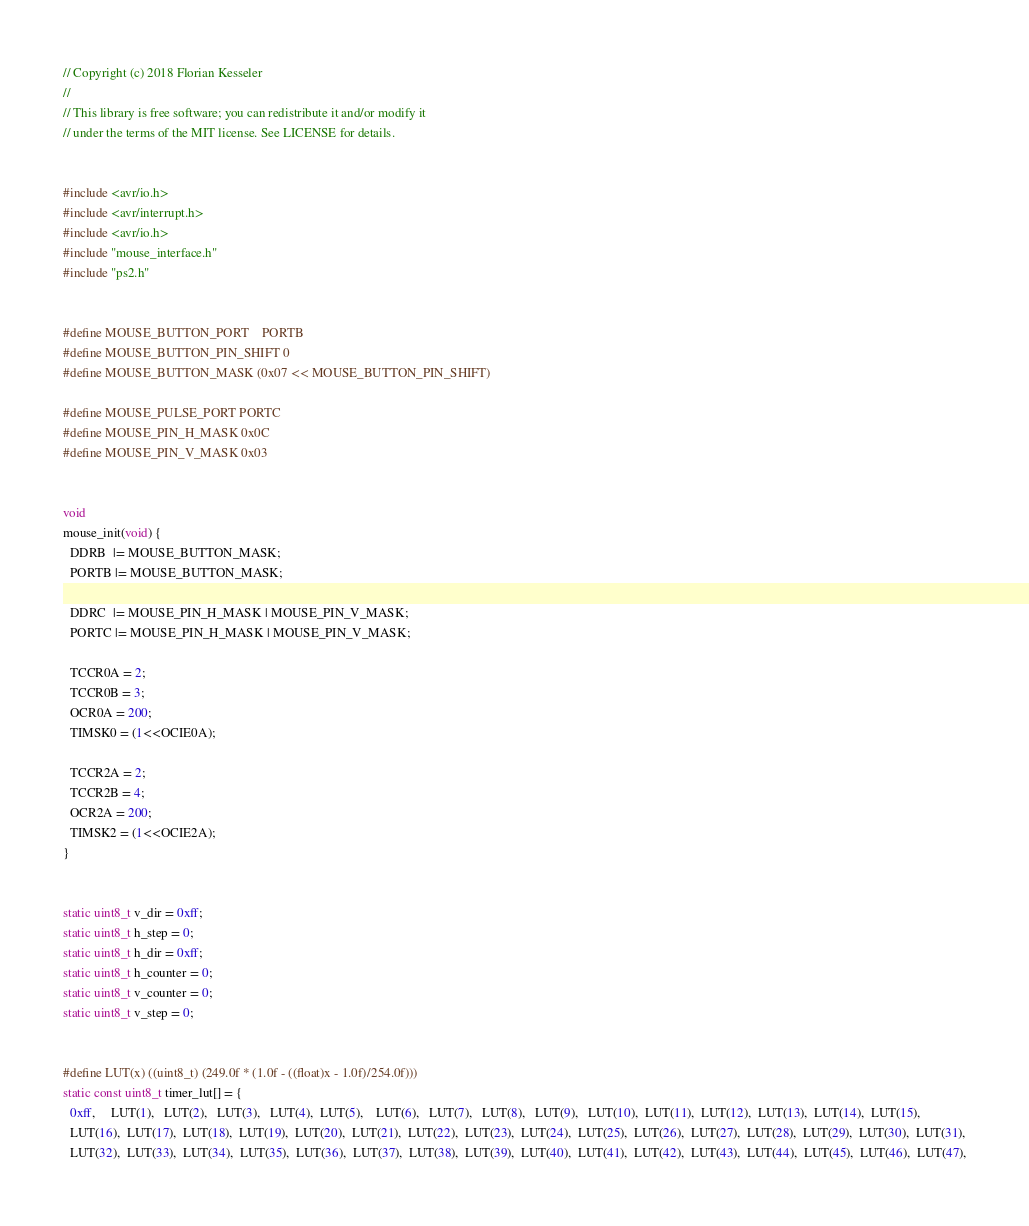<code> <loc_0><loc_0><loc_500><loc_500><_C_>// Copyright (c) 2018 Florian Kesseler
//
// This library is free software; you can redistribute it and/or modify it
// under the terms of the MIT license. See LICENSE for details.


#include <avr/io.h>
#include <avr/interrupt.h>
#include <avr/io.h>
#include "mouse_interface.h"
#include "ps2.h"


#define MOUSE_BUTTON_PORT    PORTB
#define MOUSE_BUTTON_PIN_SHIFT 0
#define MOUSE_BUTTON_MASK (0x07 << MOUSE_BUTTON_PIN_SHIFT)

#define MOUSE_PULSE_PORT PORTC
#define MOUSE_PIN_H_MASK 0x0C
#define MOUSE_PIN_V_MASK 0x03


void
mouse_init(void) {
  DDRB  |= MOUSE_BUTTON_MASK;
  PORTB |= MOUSE_BUTTON_MASK;

  DDRC  |= MOUSE_PIN_H_MASK | MOUSE_PIN_V_MASK;
  PORTC |= MOUSE_PIN_H_MASK | MOUSE_PIN_V_MASK;

  TCCR0A = 2;
  TCCR0B = 3;
  OCR0A = 200;
  TIMSK0 = (1<<OCIE0A);

  TCCR2A = 2;
  TCCR2B = 4;
  OCR2A = 200;
  TIMSK2 = (1<<OCIE2A);
}


static uint8_t v_dir = 0xff;
static uint8_t h_step = 0;
static uint8_t h_dir = 0xff;
static uint8_t h_counter = 0;
static uint8_t v_counter = 0;
static uint8_t v_step = 0;


#define LUT(x) ((uint8_t) (249.0f * (1.0f - ((float)x - 1.0f)/254.0f)))
static const uint8_t timer_lut[] = {
  0xff,     LUT(1),   LUT(2),   LUT(3),   LUT(4),  LUT(5),    LUT(6),   LUT(7),   LUT(8),   LUT(9),   LUT(10),  LUT(11),  LUT(12),  LUT(13),  LUT(14),  LUT(15),
  LUT(16),  LUT(17),  LUT(18),  LUT(19),  LUT(20),  LUT(21),  LUT(22),  LUT(23),  LUT(24),  LUT(25),  LUT(26),  LUT(27),  LUT(28),  LUT(29),  LUT(30),  LUT(31),
  LUT(32),  LUT(33),  LUT(34),  LUT(35),  LUT(36),  LUT(37),  LUT(38),  LUT(39),  LUT(40),  LUT(41),  LUT(42),  LUT(43),  LUT(44),  LUT(45),  LUT(46),  LUT(47),</code> 